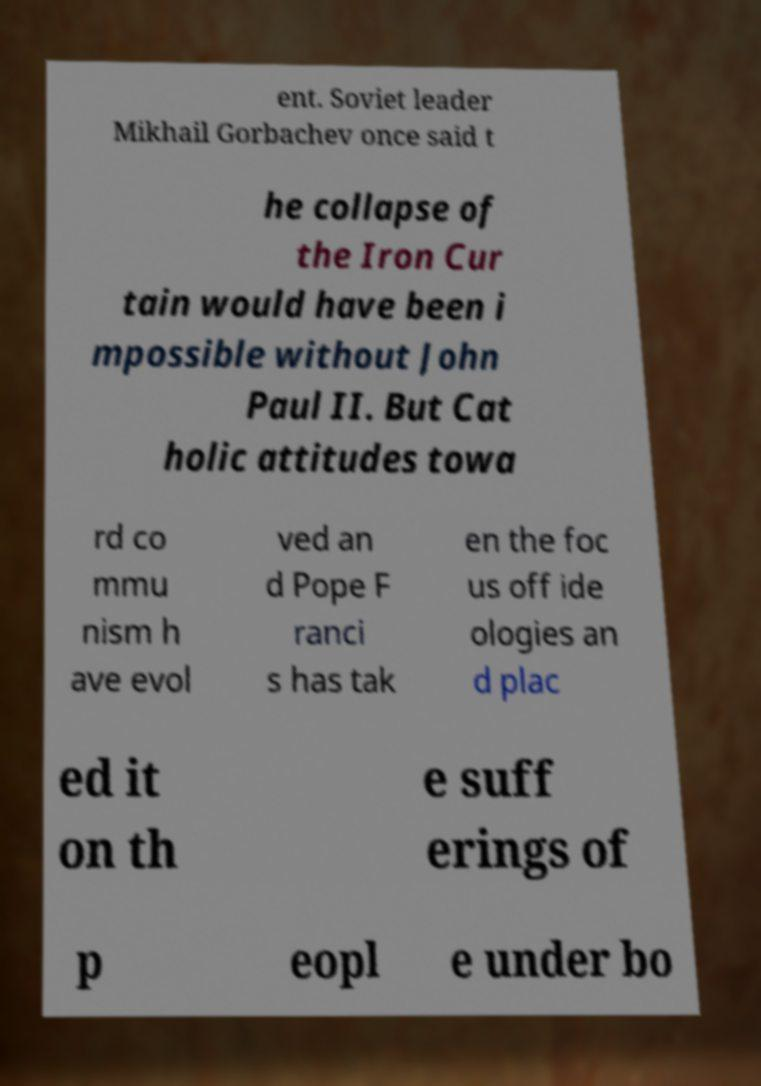What messages or text are displayed in this image? I need them in a readable, typed format. ent. Soviet leader Mikhail Gorbachev once said t he collapse of the Iron Cur tain would have been i mpossible without John Paul II. But Cat holic attitudes towa rd co mmu nism h ave evol ved an d Pope F ranci s has tak en the foc us off ide ologies an d plac ed it on th e suff erings of p eopl e under bo 